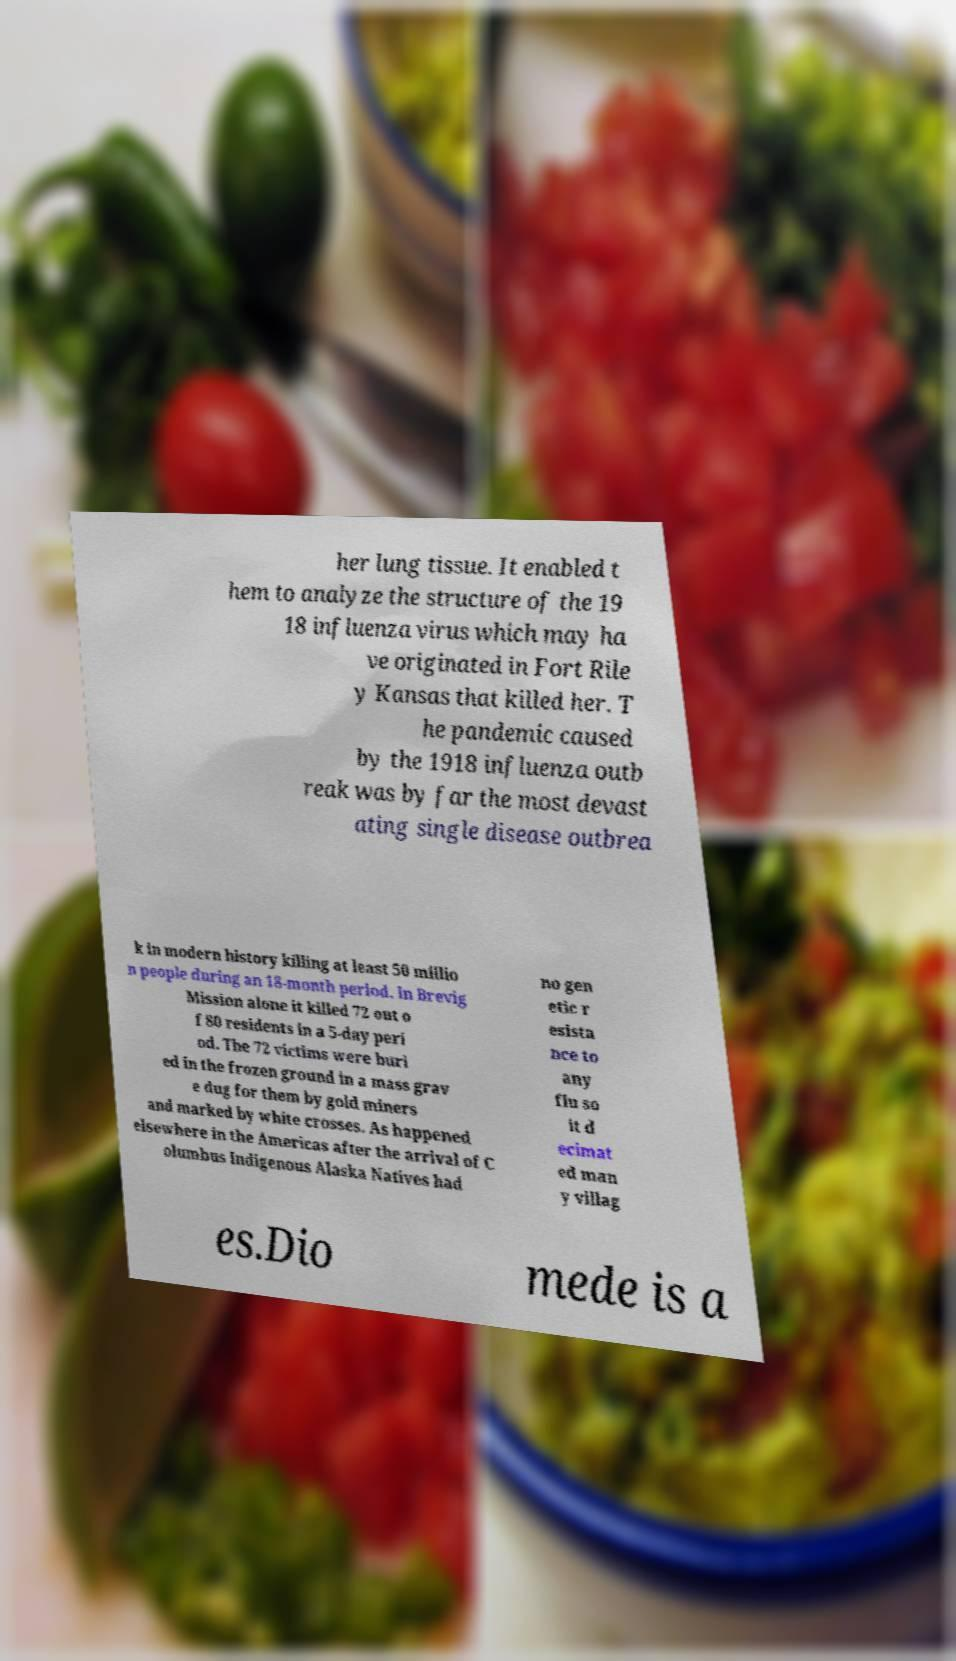Could you assist in decoding the text presented in this image and type it out clearly? her lung tissue. It enabled t hem to analyze the structure of the 19 18 influenza virus which may ha ve originated in Fort Rile y Kansas that killed her. T he pandemic caused by the 1918 influenza outb reak was by far the most devast ating single disease outbrea k in modern history killing at least 50 millio n people during an 18-month period. In Brevig Mission alone it killed 72 out o f 80 residents in a 5-day peri od. The 72 victims were buri ed in the frozen ground in a mass grav e dug for them by gold miners and marked by white crosses. As happened elsewhere in the Americas after the arrival of C olumbus Indigenous Alaska Natives had no gen etic r esista nce to any flu so it d ecimat ed man y villag es.Dio mede is a 